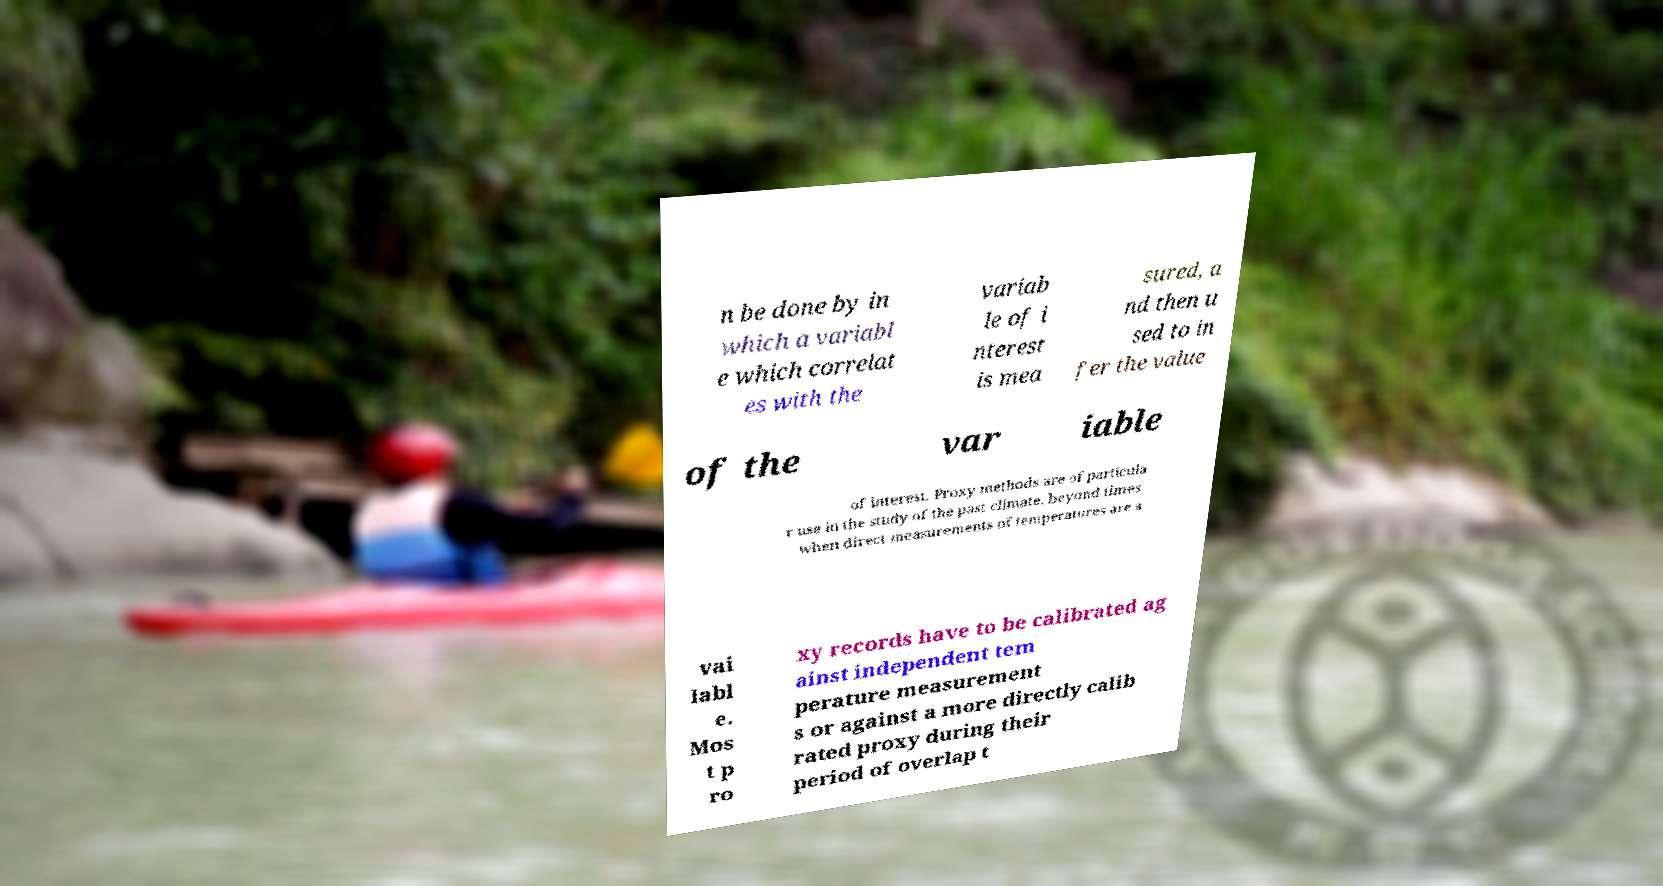Could you assist in decoding the text presented in this image and type it out clearly? n be done by in which a variabl e which correlat es with the variab le of i nterest is mea sured, a nd then u sed to in fer the value of the var iable of interest. Proxy methods are of particula r use in the study of the past climate, beyond times when direct measurements of temperatures are a vai labl e. Mos t p ro xy records have to be calibrated ag ainst independent tem perature measurement s or against a more directly calib rated proxy during their period of overlap t 